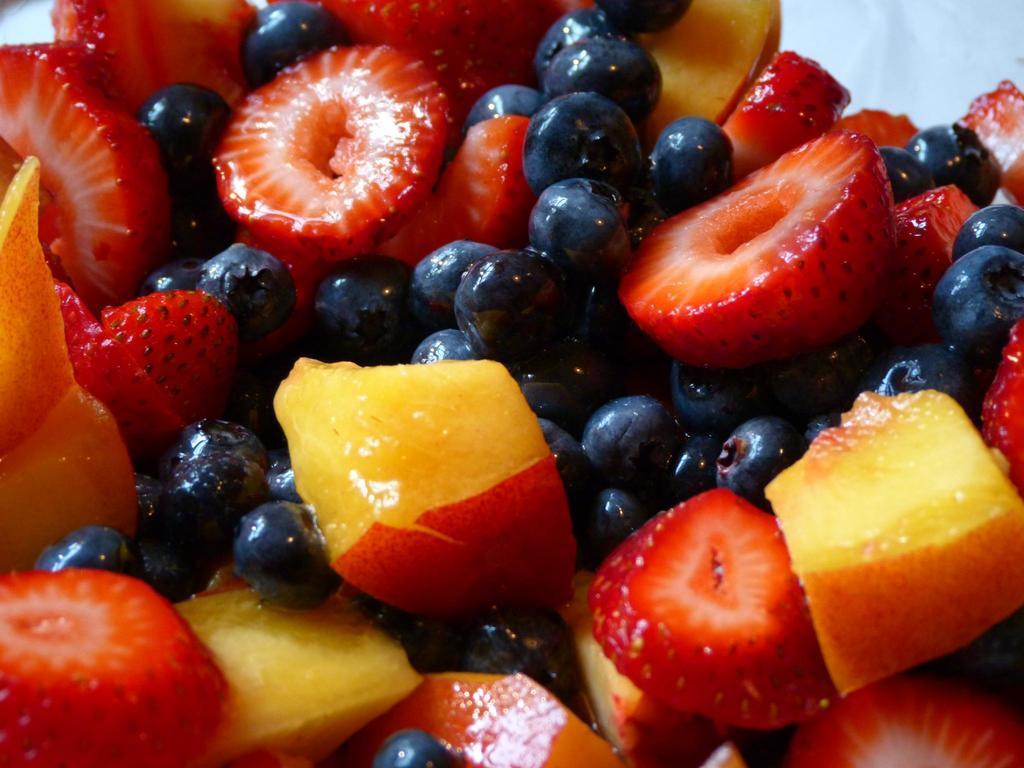Please provide a concise description of this image. In the center of the image we can see cut fruits. 